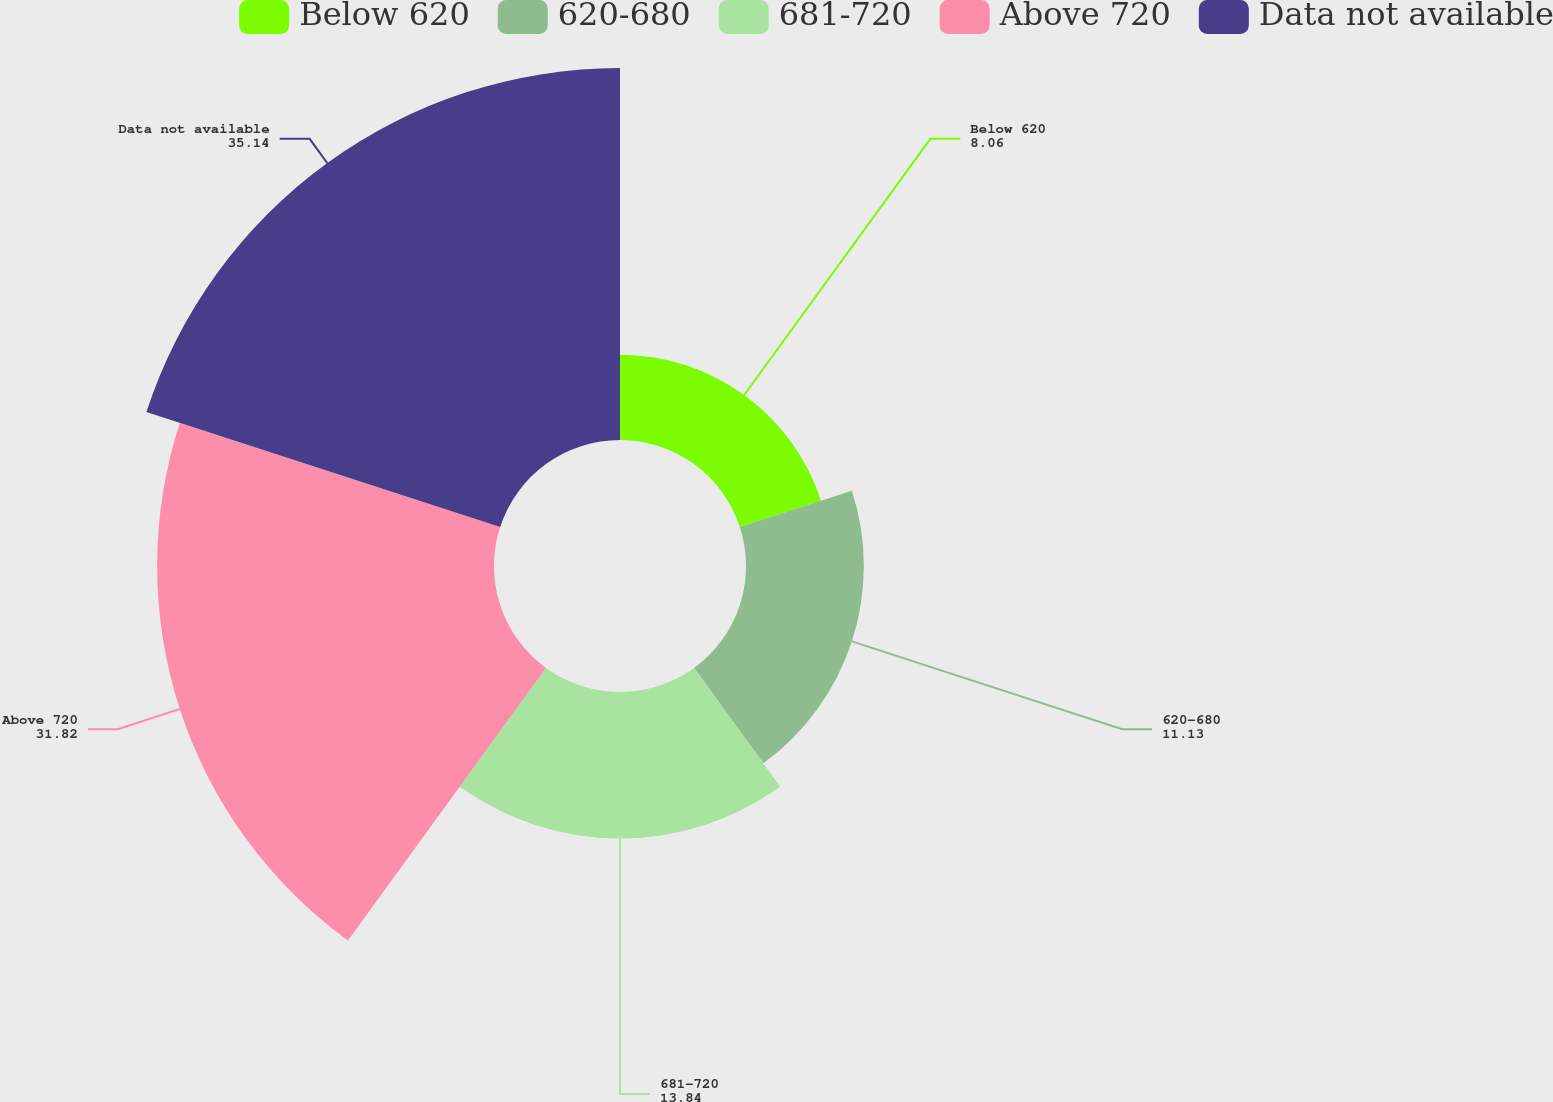<chart> <loc_0><loc_0><loc_500><loc_500><pie_chart><fcel>Below 620<fcel>620-680<fcel>681-720<fcel>Above 720<fcel>Data not available<nl><fcel>8.06%<fcel>11.13%<fcel>13.84%<fcel>31.82%<fcel>35.14%<nl></chart> 